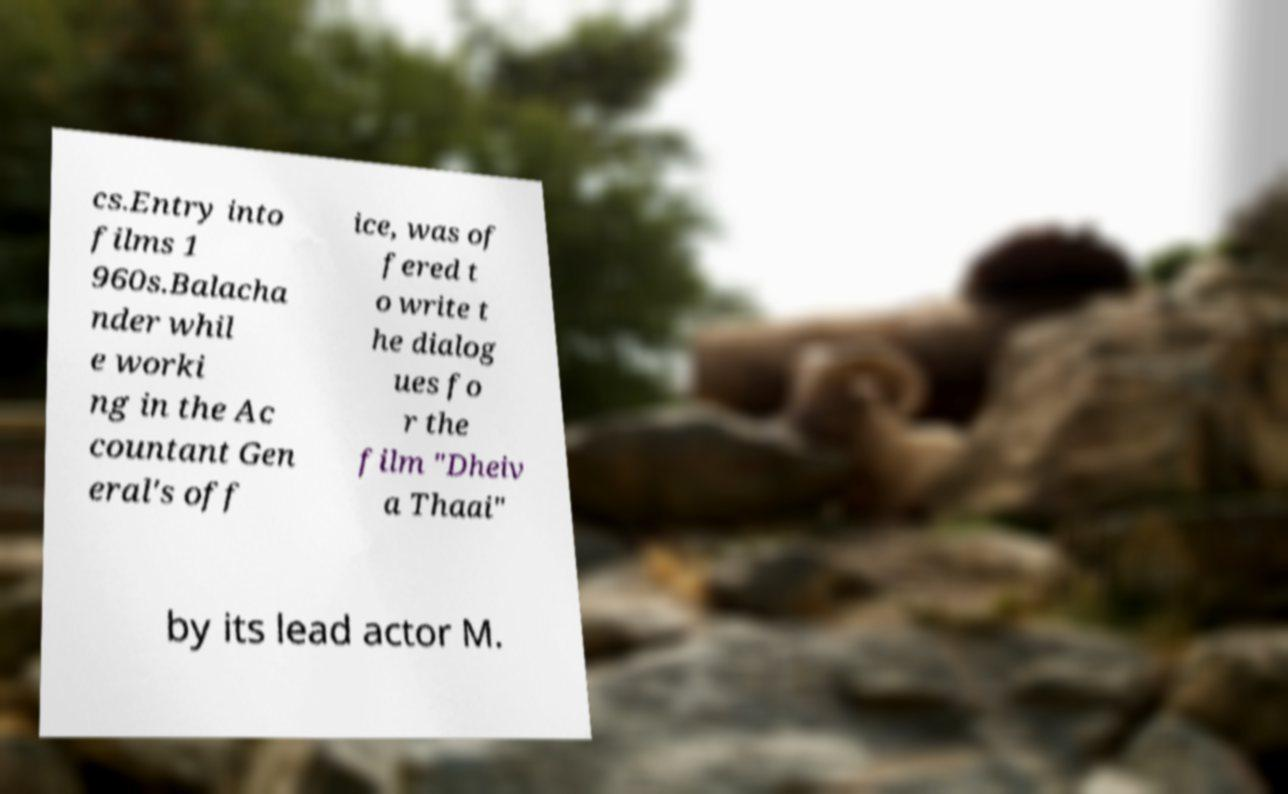What messages or text are displayed in this image? I need them in a readable, typed format. cs.Entry into films 1 960s.Balacha nder whil e worki ng in the Ac countant Gen eral's off ice, was of fered t o write t he dialog ues fo r the film "Dheiv a Thaai" by its lead actor M. 